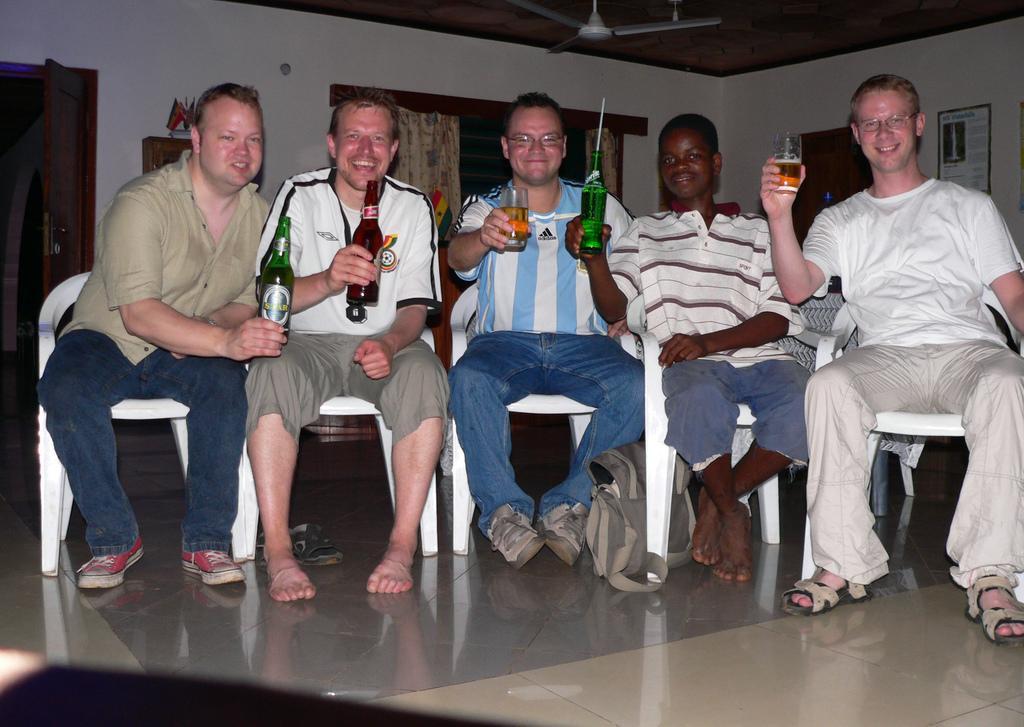Please provide a concise description of this image. In this image in the center there are some people sitting on chairs and they are holding bottles and glasses, in the bottles and glasses there is drink and there is one bag on the floor. And at the bottom there is floor, and in the background there are doors, curtains, wall and posters and at the top there is ceiling and fan. 